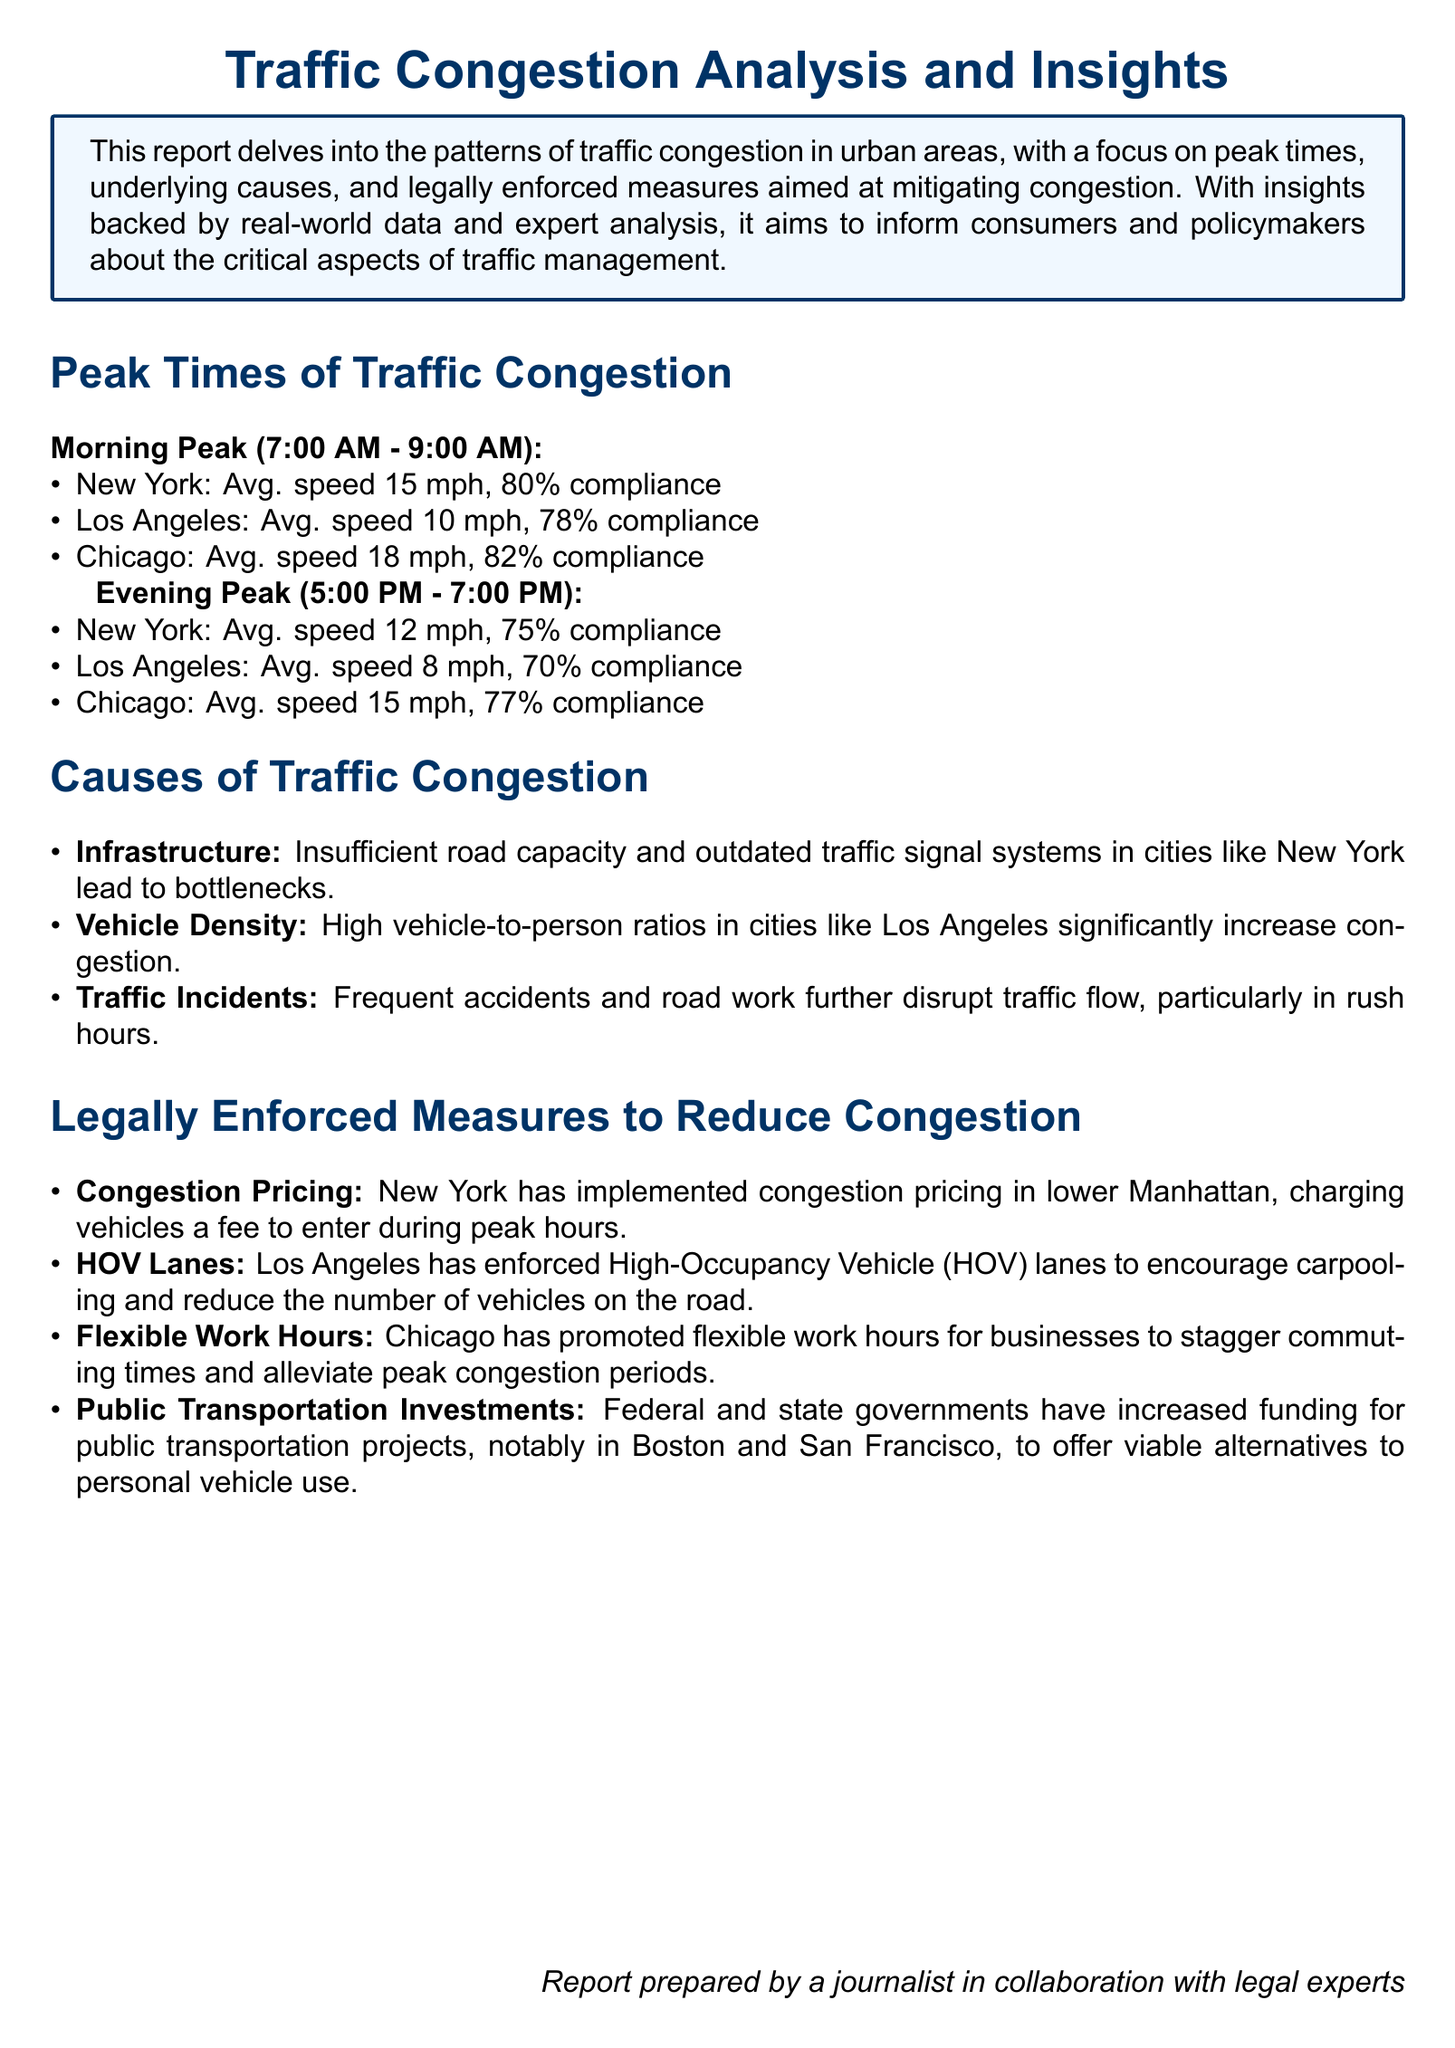what is the average speed during the morning peak in New York? The average speed during the morning peak in New York, as stated in the report, is 15 mph.
Answer: 15 mph what percentage of compliance is noted for Los Angeles during the evening peak? The report indicates a compliance rate of 70% for Los Angeles during the evening peak.
Answer: 70% which city has the highest average speed during the evening peak? Chicago has the highest average speed during the evening peak at 15 mph, according to the report.
Answer: Chicago what is one cause of traffic congestion mentioned in the report? The report lists "Insufficient road capacity" as one of the causes of traffic congestion.
Answer: Insufficient road capacity what legally enforced measure is implemented in New York to reduce congestion? The report mentions that New York has implemented "congestion pricing" to reduce congestion.
Answer: congestion pricing which vehicle density issue is highlighted in Los Angeles? The report highlights "high vehicle-to-person ratios" as an issue contributing to congestion in Los Angeles.
Answer: high vehicle-to-person ratios what time frame is indicated as the morning peak? The report specifies the morning peak as occurring between 7:00 AM and 9:00 AM.
Answer: 7:00 AM - 9:00 AM which approach is used by Chicago to alleviate peak congestion? The report states that Chicago promotes "flexible work hours" to alleviate peak congestion.
Answer: flexible work hours what was the average speed in Los Angeles during the morning peak? The average speed in Los Angeles during the morning peak, as indicated in the report, is 10 mph.
Answer: 10 mph 